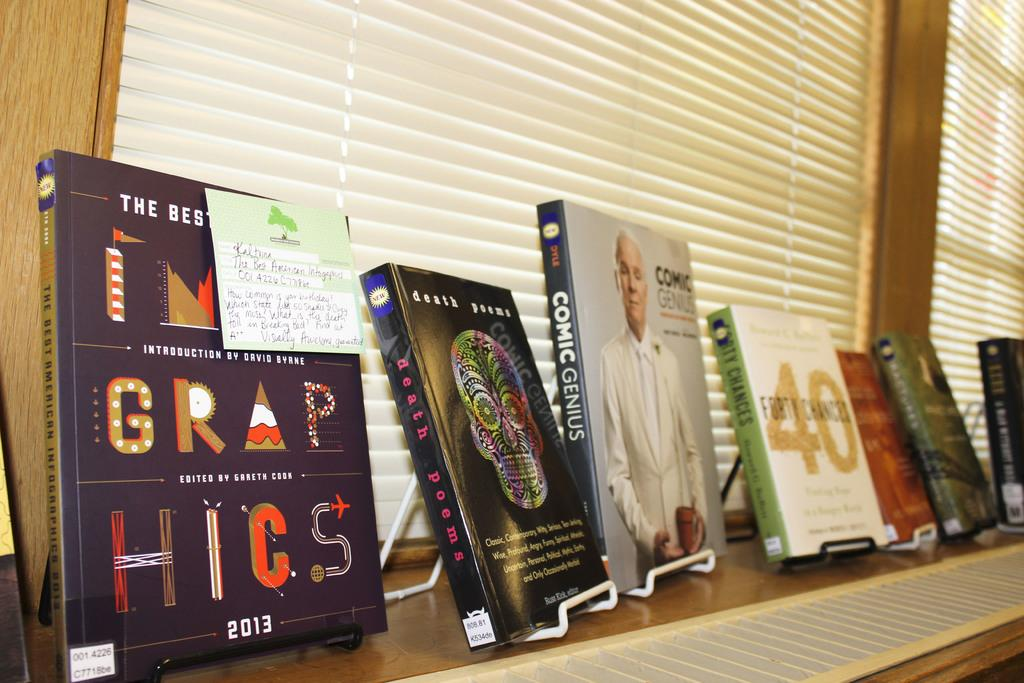Provide a one-sentence caption for the provided image. Various books are displayed that include Grap Hicks and Comic Genius. 